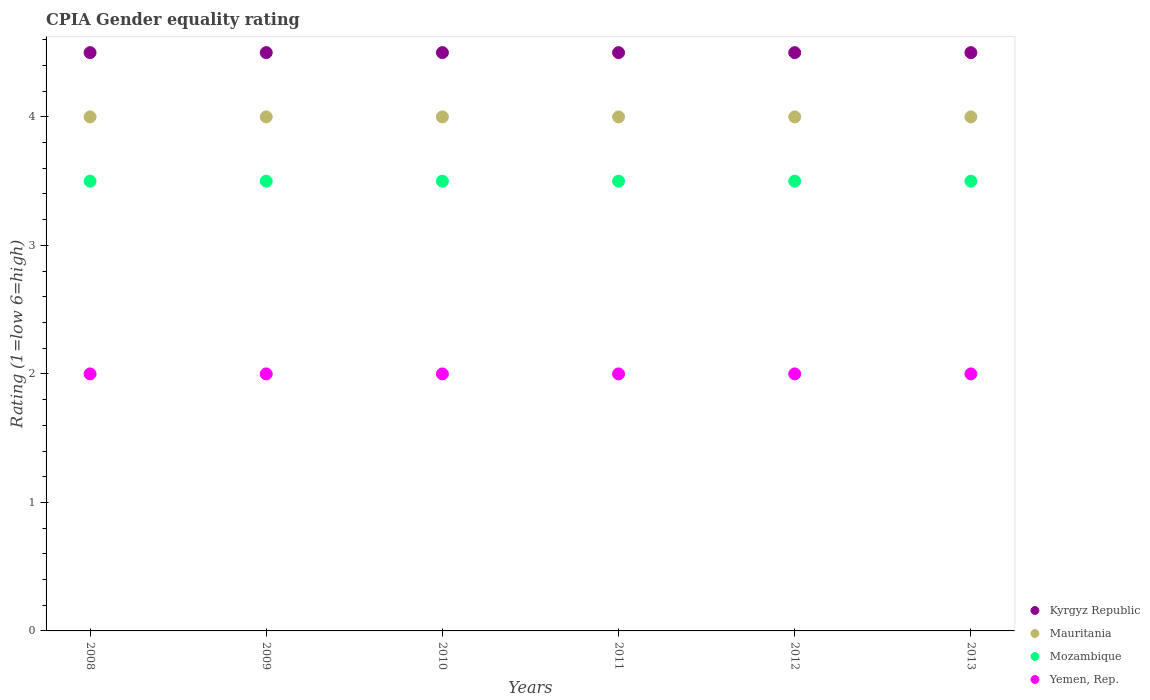How many different coloured dotlines are there?
Keep it short and to the point. 4. Across all years, what is the minimum CPIA rating in Yemen, Rep.?
Provide a succinct answer. 2. What is the total CPIA rating in Kyrgyz Republic in the graph?
Ensure brevity in your answer.  27. What is the difference between the CPIA rating in Yemen, Rep. in 2008 and that in 2010?
Keep it short and to the point. 0. What is the difference between the CPIA rating in Mauritania in 2013 and the CPIA rating in Kyrgyz Republic in 2008?
Give a very brief answer. -0.5. What is the average CPIA rating in Kyrgyz Republic per year?
Offer a very short reply. 4.5. What is the ratio of the CPIA rating in Mauritania in 2011 to that in 2012?
Make the answer very short. 1. Is the CPIA rating in Mauritania in 2009 less than that in 2012?
Your response must be concise. No. Is the difference between the CPIA rating in Mozambique in 2009 and 2013 greater than the difference between the CPIA rating in Yemen, Rep. in 2009 and 2013?
Your answer should be compact. No. What is the difference between the highest and the second highest CPIA rating in Mauritania?
Your answer should be compact. 0. What is the difference between the highest and the lowest CPIA rating in Kyrgyz Republic?
Keep it short and to the point. 0. Is the sum of the CPIA rating in Kyrgyz Republic in 2012 and 2013 greater than the maximum CPIA rating in Mozambique across all years?
Keep it short and to the point. Yes. Is it the case that in every year, the sum of the CPIA rating in Mozambique and CPIA rating in Yemen, Rep.  is greater than the CPIA rating in Kyrgyz Republic?
Give a very brief answer. Yes. Does the CPIA rating in Mozambique monotonically increase over the years?
Provide a succinct answer. No. Is the CPIA rating in Kyrgyz Republic strictly greater than the CPIA rating in Yemen, Rep. over the years?
Your response must be concise. Yes. Does the graph contain any zero values?
Your response must be concise. No. Does the graph contain grids?
Offer a very short reply. No. Where does the legend appear in the graph?
Give a very brief answer. Bottom right. How many legend labels are there?
Make the answer very short. 4. How are the legend labels stacked?
Your answer should be compact. Vertical. What is the title of the graph?
Keep it short and to the point. CPIA Gender equality rating. What is the label or title of the Y-axis?
Give a very brief answer. Rating (1=low 6=high). What is the Rating (1=low 6=high) of Kyrgyz Republic in 2008?
Keep it short and to the point. 4.5. What is the Rating (1=low 6=high) of Yemen, Rep. in 2008?
Offer a terse response. 2. What is the Rating (1=low 6=high) of Kyrgyz Republic in 2009?
Offer a very short reply. 4.5. What is the Rating (1=low 6=high) in Mauritania in 2009?
Provide a short and direct response. 4. What is the Rating (1=low 6=high) in Kyrgyz Republic in 2010?
Offer a terse response. 4.5. What is the Rating (1=low 6=high) of Mauritania in 2010?
Your answer should be compact. 4. What is the Rating (1=low 6=high) of Mozambique in 2010?
Offer a very short reply. 3.5. What is the Rating (1=low 6=high) in Kyrgyz Republic in 2011?
Ensure brevity in your answer.  4.5. What is the Rating (1=low 6=high) in Mauritania in 2011?
Your response must be concise. 4. What is the Rating (1=low 6=high) of Mozambique in 2011?
Give a very brief answer. 3.5. What is the Rating (1=low 6=high) of Yemen, Rep. in 2011?
Provide a short and direct response. 2. What is the Rating (1=low 6=high) of Kyrgyz Republic in 2012?
Give a very brief answer. 4.5. What is the Rating (1=low 6=high) in Mauritania in 2012?
Your answer should be very brief. 4. What is the Rating (1=low 6=high) in Mozambique in 2012?
Your response must be concise. 3.5. What is the Rating (1=low 6=high) in Kyrgyz Republic in 2013?
Offer a very short reply. 4.5. Across all years, what is the maximum Rating (1=low 6=high) in Yemen, Rep.?
Provide a succinct answer. 2. Across all years, what is the minimum Rating (1=low 6=high) in Kyrgyz Republic?
Your answer should be very brief. 4.5. What is the total Rating (1=low 6=high) of Mauritania in the graph?
Give a very brief answer. 24. What is the total Rating (1=low 6=high) of Mozambique in the graph?
Your answer should be compact. 21. What is the difference between the Rating (1=low 6=high) in Mozambique in 2008 and that in 2009?
Give a very brief answer. 0. What is the difference between the Rating (1=low 6=high) in Yemen, Rep. in 2008 and that in 2009?
Give a very brief answer. 0. What is the difference between the Rating (1=low 6=high) in Mauritania in 2008 and that in 2010?
Keep it short and to the point. 0. What is the difference between the Rating (1=low 6=high) of Mozambique in 2008 and that in 2010?
Offer a terse response. 0. What is the difference between the Rating (1=low 6=high) in Yemen, Rep. in 2008 and that in 2010?
Give a very brief answer. 0. What is the difference between the Rating (1=low 6=high) of Kyrgyz Republic in 2008 and that in 2011?
Your answer should be very brief. 0. What is the difference between the Rating (1=low 6=high) of Mozambique in 2008 and that in 2011?
Provide a short and direct response. 0. What is the difference between the Rating (1=low 6=high) of Kyrgyz Republic in 2008 and that in 2012?
Ensure brevity in your answer.  0. What is the difference between the Rating (1=low 6=high) in Mozambique in 2008 and that in 2012?
Your answer should be compact. 0. What is the difference between the Rating (1=low 6=high) in Kyrgyz Republic in 2008 and that in 2013?
Keep it short and to the point. 0. What is the difference between the Rating (1=low 6=high) in Mauritania in 2008 and that in 2013?
Your answer should be very brief. 0. What is the difference between the Rating (1=low 6=high) of Mozambique in 2008 and that in 2013?
Provide a short and direct response. 0. What is the difference between the Rating (1=low 6=high) of Yemen, Rep. in 2008 and that in 2013?
Your response must be concise. 0. What is the difference between the Rating (1=low 6=high) in Yemen, Rep. in 2009 and that in 2010?
Keep it short and to the point. 0. What is the difference between the Rating (1=low 6=high) in Kyrgyz Republic in 2009 and that in 2011?
Your response must be concise. 0. What is the difference between the Rating (1=low 6=high) in Mauritania in 2009 and that in 2011?
Ensure brevity in your answer.  0. What is the difference between the Rating (1=low 6=high) in Mozambique in 2009 and that in 2011?
Your answer should be very brief. 0. What is the difference between the Rating (1=low 6=high) in Kyrgyz Republic in 2009 and that in 2012?
Your answer should be very brief. 0. What is the difference between the Rating (1=low 6=high) in Mauritania in 2009 and that in 2012?
Give a very brief answer. 0. What is the difference between the Rating (1=low 6=high) of Mozambique in 2009 and that in 2012?
Provide a succinct answer. 0. What is the difference between the Rating (1=low 6=high) in Mauritania in 2009 and that in 2013?
Provide a succinct answer. 0. What is the difference between the Rating (1=low 6=high) of Mozambique in 2009 and that in 2013?
Make the answer very short. 0. What is the difference between the Rating (1=low 6=high) of Yemen, Rep. in 2009 and that in 2013?
Keep it short and to the point. 0. What is the difference between the Rating (1=low 6=high) of Yemen, Rep. in 2010 and that in 2011?
Keep it short and to the point. 0. What is the difference between the Rating (1=low 6=high) of Mozambique in 2010 and that in 2012?
Ensure brevity in your answer.  0. What is the difference between the Rating (1=low 6=high) in Yemen, Rep. in 2010 and that in 2012?
Offer a very short reply. 0. What is the difference between the Rating (1=low 6=high) of Kyrgyz Republic in 2011 and that in 2012?
Ensure brevity in your answer.  0. What is the difference between the Rating (1=low 6=high) of Mauritania in 2011 and that in 2012?
Offer a terse response. 0. What is the difference between the Rating (1=low 6=high) in Mozambique in 2011 and that in 2012?
Provide a succinct answer. 0. What is the difference between the Rating (1=low 6=high) of Mozambique in 2011 and that in 2013?
Offer a terse response. 0. What is the difference between the Rating (1=low 6=high) of Kyrgyz Republic in 2008 and the Rating (1=low 6=high) of Yemen, Rep. in 2009?
Offer a terse response. 2.5. What is the difference between the Rating (1=low 6=high) of Mauritania in 2008 and the Rating (1=low 6=high) of Mozambique in 2009?
Ensure brevity in your answer.  0.5. What is the difference between the Rating (1=low 6=high) of Mauritania in 2008 and the Rating (1=low 6=high) of Yemen, Rep. in 2009?
Offer a very short reply. 2. What is the difference between the Rating (1=low 6=high) in Kyrgyz Republic in 2008 and the Rating (1=low 6=high) in Mauritania in 2010?
Keep it short and to the point. 0.5. What is the difference between the Rating (1=low 6=high) of Mauritania in 2008 and the Rating (1=low 6=high) of Mozambique in 2010?
Your answer should be compact. 0.5. What is the difference between the Rating (1=low 6=high) in Mauritania in 2008 and the Rating (1=low 6=high) in Yemen, Rep. in 2010?
Keep it short and to the point. 2. What is the difference between the Rating (1=low 6=high) of Mozambique in 2008 and the Rating (1=low 6=high) of Yemen, Rep. in 2010?
Your response must be concise. 1.5. What is the difference between the Rating (1=low 6=high) in Kyrgyz Republic in 2008 and the Rating (1=low 6=high) in Mauritania in 2011?
Ensure brevity in your answer.  0.5. What is the difference between the Rating (1=low 6=high) in Kyrgyz Republic in 2008 and the Rating (1=low 6=high) in Mozambique in 2011?
Your answer should be compact. 1. What is the difference between the Rating (1=low 6=high) in Mauritania in 2008 and the Rating (1=low 6=high) in Yemen, Rep. in 2011?
Your answer should be very brief. 2. What is the difference between the Rating (1=low 6=high) of Kyrgyz Republic in 2008 and the Rating (1=low 6=high) of Mauritania in 2012?
Ensure brevity in your answer.  0.5. What is the difference between the Rating (1=low 6=high) of Kyrgyz Republic in 2008 and the Rating (1=low 6=high) of Mozambique in 2012?
Provide a succinct answer. 1. What is the difference between the Rating (1=low 6=high) of Kyrgyz Republic in 2008 and the Rating (1=low 6=high) of Yemen, Rep. in 2012?
Provide a short and direct response. 2.5. What is the difference between the Rating (1=low 6=high) in Kyrgyz Republic in 2008 and the Rating (1=low 6=high) in Mauritania in 2013?
Your response must be concise. 0.5. What is the difference between the Rating (1=low 6=high) in Kyrgyz Republic in 2009 and the Rating (1=low 6=high) in Mozambique in 2010?
Keep it short and to the point. 1. What is the difference between the Rating (1=low 6=high) in Kyrgyz Republic in 2009 and the Rating (1=low 6=high) in Yemen, Rep. in 2010?
Give a very brief answer. 2.5. What is the difference between the Rating (1=low 6=high) in Mauritania in 2009 and the Rating (1=low 6=high) in Mozambique in 2010?
Your answer should be very brief. 0.5. What is the difference between the Rating (1=low 6=high) in Kyrgyz Republic in 2009 and the Rating (1=low 6=high) in Yemen, Rep. in 2011?
Provide a succinct answer. 2.5. What is the difference between the Rating (1=low 6=high) of Mozambique in 2009 and the Rating (1=low 6=high) of Yemen, Rep. in 2011?
Offer a very short reply. 1.5. What is the difference between the Rating (1=low 6=high) of Kyrgyz Republic in 2009 and the Rating (1=low 6=high) of Mauritania in 2012?
Offer a very short reply. 0.5. What is the difference between the Rating (1=low 6=high) of Kyrgyz Republic in 2009 and the Rating (1=low 6=high) of Mozambique in 2012?
Give a very brief answer. 1. What is the difference between the Rating (1=low 6=high) in Kyrgyz Republic in 2009 and the Rating (1=low 6=high) in Yemen, Rep. in 2012?
Provide a succinct answer. 2.5. What is the difference between the Rating (1=low 6=high) in Mauritania in 2009 and the Rating (1=low 6=high) in Mozambique in 2012?
Give a very brief answer. 0.5. What is the difference between the Rating (1=low 6=high) of Mauritania in 2009 and the Rating (1=low 6=high) of Yemen, Rep. in 2012?
Offer a terse response. 2. What is the difference between the Rating (1=low 6=high) of Kyrgyz Republic in 2009 and the Rating (1=low 6=high) of Yemen, Rep. in 2013?
Your response must be concise. 2.5. What is the difference between the Rating (1=low 6=high) of Mauritania in 2009 and the Rating (1=low 6=high) of Mozambique in 2013?
Offer a very short reply. 0.5. What is the difference between the Rating (1=low 6=high) of Kyrgyz Republic in 2010 and the Rating (1=low 6=high) of Mauritania in 2011?
Provide a short and direct response. 0.5. What is the difference between the Rating (1=low 6=high) in Kyrgyz Republic in 2010 and the Rating (1=low 6=high) in Yemen, Rep. in 2011?
Your response must be concise. 2.5. What is the difference between the Rating (1=low 6=high) of Mauritania in 2010 and the Rating (1=low 6=high) of Mozambique in 2011?
Make the answer very short. 0.5. What is the difference between the Rating (1=low 6=high) in Mozambique in 2010 and the Rating (1=low 6=high) in Yemen, Rep. in 2011?
Make the answer very short. 1.5. What is the difference between the Rating (1=low 6=high) in Kyrgyz Republic in 2010 and the Rating (1=low 6=high) in Yemen, Rep. in 2012?
Your answer should be compact. 2.5. What is the difference between the Rating (1=low 6=high) in Mauritania in 2010 and the Rating (1=low 6=high) in Yemen, Rep. in 2012?
Your answer should be compact. 2. What is the difference between the Rating (1=low 6=high) of Kyrgyz Republic in 2010 and the Rating (1=low 6=high) of Mozambique in 2013?
Make the answer very short. 1. What is the difference between the Rating (1=low 6=high) of Kyrgyz Republic in 2010 and the Rating (1=low 6=high) of Yemen, Rep. in 2013?
Offer a very short reply. 2.5. What is the difference between the Rating (1=low 6=high) of Mauritania in 2010 and the Rating (1=low 6=high) of Mozambique in 2013?
Provide a short and direct response. 0.5. What is the difference between the Rating (1=low 6=high) in Mauritania in 2010 and the Rating (1=low 6=high) in Yemen, Rep. in 2013?
Your answer should be compact. 2. What is the difference between the Rating (1=low 6=high) in Mozambique in 2010 and the Rating (1=low 6=high) in Yemen, Rep. in 2013?
Give a very brief answer. 1.5. What is the difference between the Rating (1=low 6=high) in Kyrgyz Republic in 2011 and the Rating (1=low 6=high) in Mozambique in 2012?
Offer a very short reply. 1. What is the difference between the Rating (1=low 6=high) of Mauritania in 2011 and the Rating (1=low 6=high) of Mozambique in 2012?
Offer a terse response. 0.5. What is the difference between the Rating (1=low 6=high) of Mozambique in 2011 and the Rating (1=low 6=high) of Yemen, Rep. in 2012?
Your response must be concise. 1.5. What is the difference between the Rating (1=low 6=high) in Mauritania in 2011 and the Rating (1=low 6=high) in Mozambique in 2013?
Offer a very short reply. 0.5. What is the difference between the Rating (1=low 6=high) of Mauritania in 2011 and the Rating (1=low 6=high) of Yemen, Rep. in 2013?
Provide a short and direct response. 2. What is the difference between the Rating (1=low 6=high) in Kyrgyz Republic in 2012 and the Rating (1=low 6=high) in Mozambique in 2013?
Keep it short and to the point. 1. What is the difference between the Rating (1=low 6=high) of Kyrgyz Republic in 2012 and the Rating (1=low 6=high) of Yemen, Rep. in 2013?
Give a very brief answer. 2.5. What is the average Rating (1=low 6=high) in Kyrgyz Republic per year?
Give a very brief answer. 4.5. What is the average Rating (1=low 6=high) of Yemen, Rep. per year?
Your response must be concise. 2. In the year 2008, what is the difference between the Rating (1=low 6=high) of Kyrgyz Republic and Rating (1=low 6=high) of Mozambique?
Keep it short and to the point. 1. In the year 2008, what is the difference between the Rating (1=low 6=high) in Kyrgyz Republic and Rating (1=low 6=high) in Yemen, Rep.?
Keep it short and to the point. 2.5. In the year 2008, what is the difference between the Rating (1=low 6=high) in Mauritania and Rating (1=low 6=high) in Mozambique?
Your answer should be very brief. 0.5. In the year 2008, what is the difference between the Rating (1=low 6=high) in Mauritania and Rating (1=low 6=high) in Yemen, Rep.?
Keep it short and to the point. 2. In the year 2009, what is the difference between the Rating (1=low 6=high) of Kyrgyz Republic and Rating (1=low 6=high) of Mauritania?
Your answer should be very brief. 0.5. In the year 2009, what is the difference between the Rating (1=low 6=high) in Kyrgyz Republic and Rating (1=low 6=high) in Mozambique?
Make the answer very short. 1. In the year 2009, what is the difference between the Rating (1=low 6=high) in Mauritania and Rating (1=low 6=high) in Yemen, Rep.?
Keep it short and to the point. 2. In the year 2010, what is the difference between the Rating (1=low 6=high) in Kyrgyz Republic and Rating (1=low 6=high) in Mauritania?
Keep it short and to the point. 0.5. In the year 2010, what is the difference between the Rating (1=low 6=high) of Kyrgyz Republic and Rating (1=low 6=high) of Yemen, Rep.?
Give a very brief answer. 2.5. In the year 2010, what is the difference between the Rating (1=low 6=high) in Mozambique and Rating (1=low 6=high) in Yemen, Rep.?
Ensure brevity in your answer.  1.5. In the year 2011, what is the difference between the Rating (1=low 6=high) in Kyrgyz Republic and Rating (1=low 6=high) in Yemen, Rep.?
Keep it short and to the point. 2.5. In the year 2011, what is the difference between the Rating (1=low 6=high) of Mauritania and Rating (1=low 6=high) of Mozambique?
Give a very brief answer. 0.5. In the year 2011, what is the difference between the Rating (1=low 6=high) in Mauritania and Rating (1=low 6=high) in Yemen, Rep.?
Your response must be concise. 2. In the year 2011, what is the difference between the Rating (1=low 6=high) in Mozambique and Rating (1=low 6=high) in Yemen, Rep.?
Keep it short and to the point. 1.5. In the year 2012, what is the difference between the Rating (1=low 6=high) in Kyrgyz Republic and Rating (1=low 6=high) in Mozambique?
Offer a very short reply. 1. In the year 2012, what is the difference between the Rating (1=low 6=high) in Mauritania and Rating (1=low 6=high) in Mozambique?
Ensure brevity in your answer.  0.5. In the year 2012, what is the difference between the Rating (1=low 6=high) of Mauritania and Rating (1=low 6=high) of Yemen, Rep.?
Make the answer very short. 2. In the year 2012, what is the difference between the Rating (1=low 6=high) of Mozambique and Rating (1=low 6=high) of Yemen, Rep.?
Your response must be concise. 1.5. In the year 2013, what is the difference between the Rating (1=low 6=high) of Kyrgyz Republic and Rating (1=low 6=high) of Mauritania?
Your answer should be very brief. 0.5. In the year 2013, what is the difference between the Rating (1=low 6=high) in Mauritania and Rating (1=low 6=high) in Yemen, Rep.?
Your response must be concise. 2. What is the ratio of the Rating (1=low 6=high) in Mozambique in 2008 to that in 2009?
Give a very brief answer. 1. What is the ratio of the Rating (1=low 6=high) of Mauritania in 2008 to that in 2010?
Your response must be concise. 1. What is the ratio of the Rating (1=low 6=high) in Yemen, Rep. in 2008 to that in 2010?
Provide a succinct answer. 1. What is the ratio of the Rating (1=low 6=high) of Kyrgyz Republic in 2008 to that in 2012?
Offer a terse response. 1. What is the ratio of the Rating (1=low 6=high) in Mauritania in 2008 to that in 2012?
Provide a short and direct response. 1. What is the ratio of the Rating (1=low 6=high) in Mozambique in 2008 to that in 2012?
Your answer should be compact. 1. What is the ratio of the Rating (1=low 6=high) in Yemen, Rep. in 2008 to that in 2012?
Your response must be concise. 1. What is the ratio of the Rating (1=low 6=high) of Kyrgyz Republic in 2008 to that in 2013?
Your answer should be very brief. 1. What is the ratio of the Rating (1=low 6=high) of Mauritania in 2008 to that in 2013?
Provide a short and direct response. 1. What is the ratio of the Rating (1=low 6=high) of Yemen, Rep. in 2008 to that in 2013?
Your answer should be compact. 1. What is the ratio of the Rating (1=low 6=high) of Mauritania in 2009 to that in 2010?
Offer a terse response. 1. What is the ratio of the Rating (1=low 6=high) of Kyrgyz Republic in 2009 to that in 2011?
Keep it short and to the point. 1. What is the ratio of the Rating (1=low 6=high) of Mozambique in 2009 to that in 2011?
Give a very brief answer. 1. What is the ratio of the Rating (1=low 6=high) in Yemen, Rep. in 2009 to that in 2011?
Give a very brief answer. 1. What is the ratio of the Rating (1=low 6=high) of Kyrgyz Republic in 2009 to that in 2012?
Your answer should be very brief. 1. What is the ratio of the Rating (1=low 6=high) of Mauritania in 2009 to that in 2012?
Keep it short and to the point. 1. What is the ratio of the Rating (1=low 6=high) of Mozambique in 2009 to that in 2012?
Your answer should be compact. 1. What is the ratio of the Rating (1=low 6=high) of Kyrgyz Republic in 2009 to that in 2013?
Give a very brief answer. 1. What is the ratio of the Rating (1=low 6=high) of Mozambique in 2009 to that in 2013?
Offer a very short reply. 1. What is the ratio of the Rating (1=low 6=high) in Mauritania in 2010 to that in 2011?
Provide a short and direct response. 1. What is the ratio of the Rating (1=low 6=high) of Yemen, Rep. in 2010 to that in 2011?
Your answer should be very brief. 1. What is the ratio of the Rating (1=low 6=high) in Mozambique in 2010 to that in 2012?
Make the answer very short. 1. What is the ratio of the Rating (1=low 6=high) of Yemen, Rep. in 2010 to that in 2012?
Your response must be concise. 1. What is the ratio of the Rating (1=low 6=high) in Kyrgyz Republic in 2010 to that in 2013?
Give a very brief answer. 1. What is the ratio of the Rating (1=low 6=high) of Mauritania in 2010 to that in 2013?
Keep it short and to the point. 1. What is the ratio of the Rating (1=low 6=high) in Yemen, Rep. in 2010 to that in 2013?
Your response must be concise. 1. What is the ratio of the Rating (1=low 6=high) in Mozambique in 2011 to that in 2012?
Offer a terse response. 1. What is the ratio of the Rating (1=low 6=high) in Yemen, Rep. in 2011 to that in 2013?
Give a very brief answer. 1. What is the ratio of the Rating (1=low 6=high) of Mozambique in 2012 to that in 2013?
Provide a succinct answer. 1. What is the difference between the highest and the second highest Rating (1=low 6=high) in Kyrgyz Republic?
Offer a terse response. 0. What is the difference between the highest and the second highest Rating (1=low 6=high) in Mauritania?
Give a very brief answer. 0. What is the difference between the highest and the second highest Rating (1=low 6=high) of Mozambique?
Your response must be concise. 0. What is the difference between the highest and the second highest Rating (1=low 6=high) of Yemen, Rep.?
Provide a succinct answer. 0. What is the difference between the highest and the lowest Rating (1=low 6=high) of Mauritania?
Give a very brief answer. 0. What is the difference between the highest and the lowest Rating (1=low 6=high) of Yemen, Rep.?
Give a very brief answer. 0. 